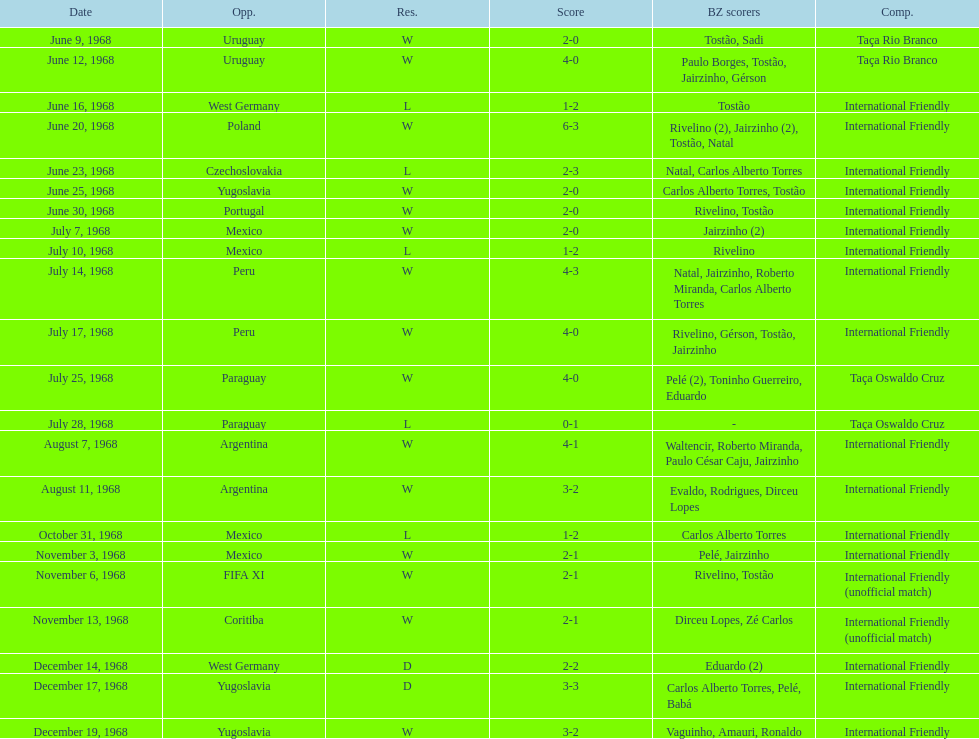Name the first competition ever played by brazil. Taça Rio Branco. 